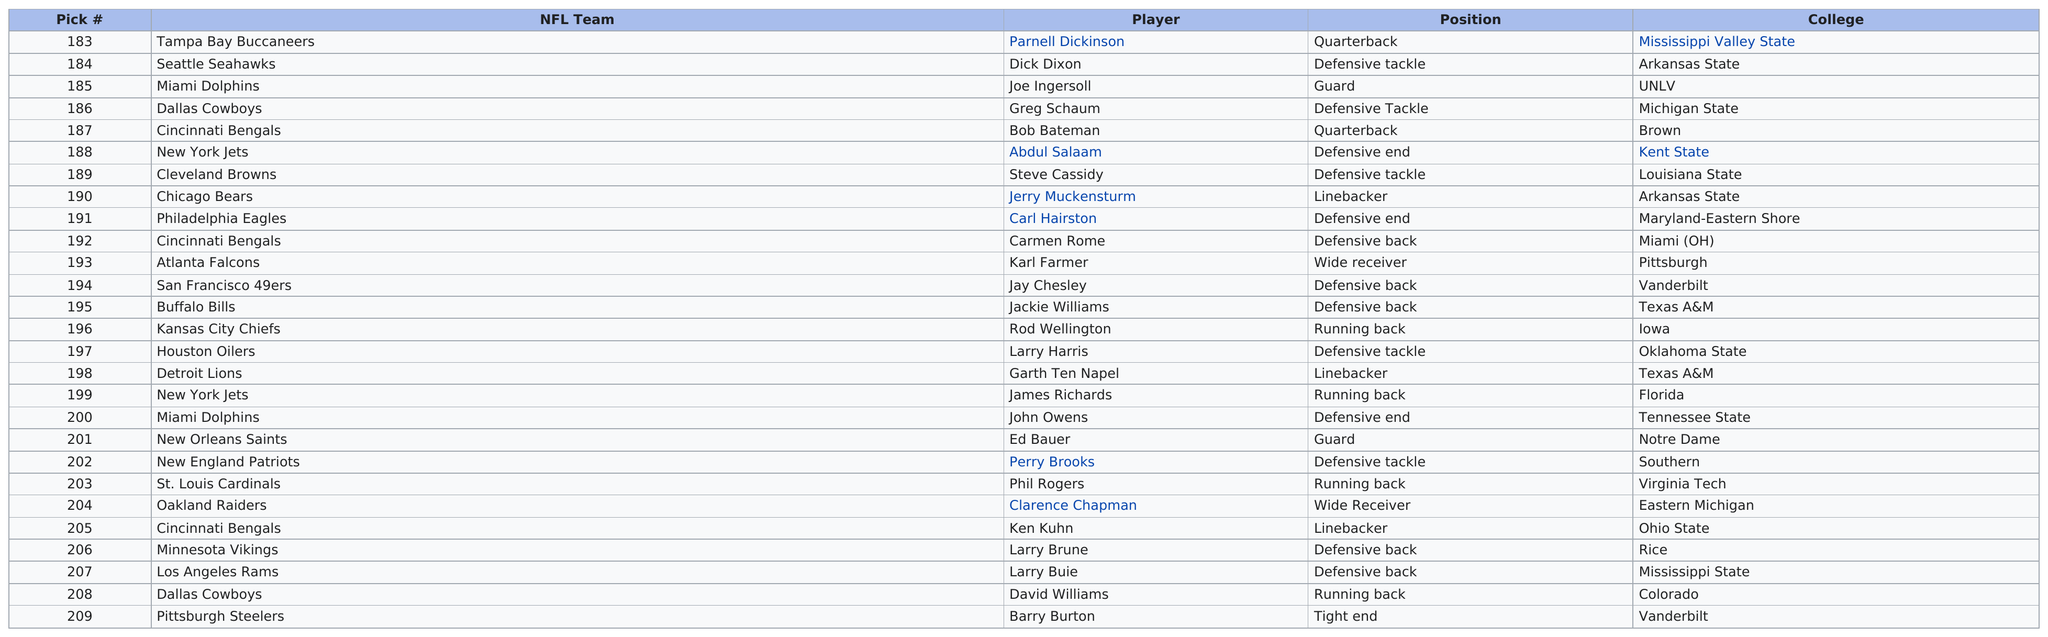Indicate a few pertinent items in this graphic. The Pittsburgh Steelers had the last pick in the National Football League (NFL). Jerry Muckensturm was the first linebacker selected in this round. In the seventh round of the draft, the Cincinnati Bengals selected Bob Bateman, making him the first player chosen by the team that year. If David Williams was chosen 208th overall and Greg Schaum was chosen 186th, then there were 22 picks between the two. Ed Bauer was selected by the New Orleans Saints and played the position of guard. 